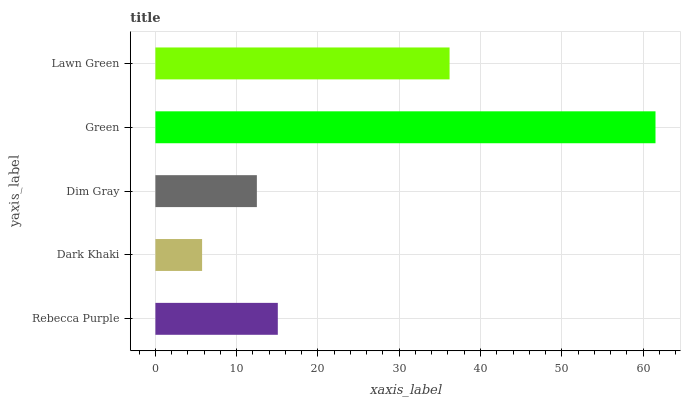Is Dark Khaki the minimum?
Answer yes or no. Yes. Is Green the maximum?
Answer yes or no. Yes. Is Dim Gray the minimum?
Answer yes or no. No. Is Dim Gray the maximum?
Answer yes or no. No. Is Dim Gray greater than Dark Khaki?
Answer yes or no. Yes. Is Dark Khaki less than Dim Gray?
Answer yes or no. Yes. Is Dark Khaki greater than Dim Gray?
Answer yes or no. No. Is Dim Gray less than Dark Khaki?
Answer yes or no. No. Is Rebecca Purple the high median?
Answer yes or no. Yes. Is Rebecca Purple the low median?
Answer yes or no. Yes. Is Lawn Green the high median?
Answer yes or no. No. Is Lawn Green the low median?
Answer yes or no. No. 